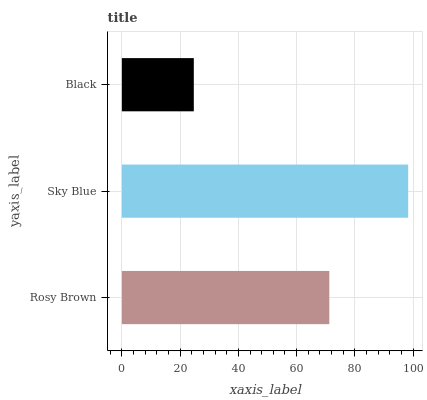Is Black the minimum?
Answer yes or no. Yes. Is Sky Blue the maximum?
Answer yes or no. Yes. Is Sky Blue the minimum?
Answer yes or no. No. Is Black the maximum?
Answer yes or no. No. Is Sky Blue greater than Black?
Answer yes or no. Yes. Is Black less than Sky Blue?
Answer yes or no. Yes. Is Black greater than Sky Blue?
Answer yes or no. No. Is Sky Blue less than Black?
Answer yes or no. No. Is Rosy Brown the high median?
Answer yes or no. Yes. Is Rosy Brown the low median?
Answer yes or no. Yes. Is Black the high median?
Answer yes or no. No. Is Sky Blue the low median?
Answer yes or no. No. 